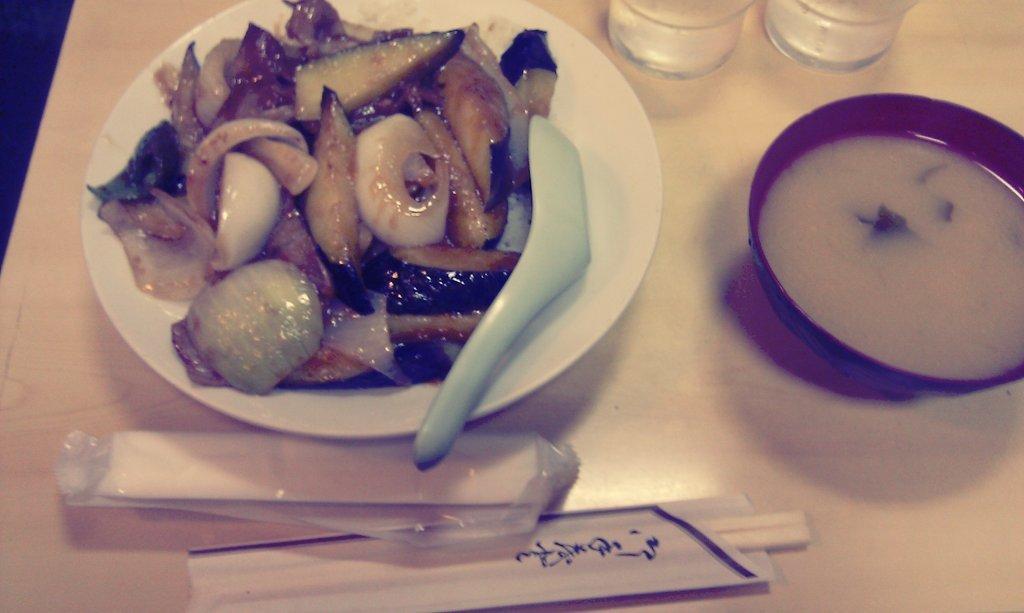Describe this image in one or two sentences. In this image, we can see some food and spoon on the plate. Here we can see chopsticks and some object. On the right side of the image, we can see a bowl with soup. Here we can see glass objects. All these items are placed on the wooden surface. Left side top corner, we can see black color. 